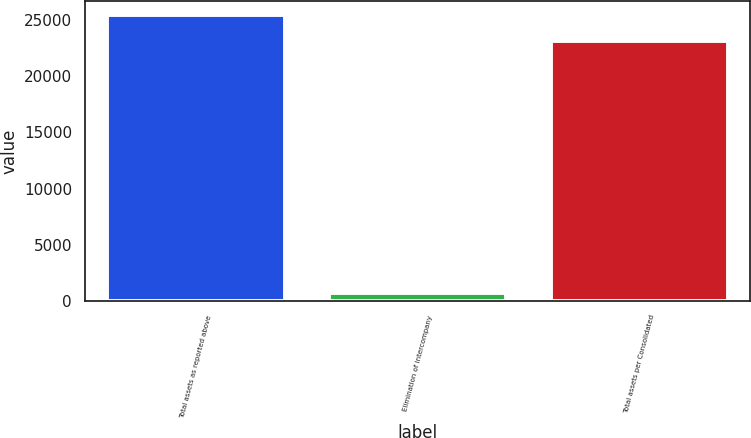<chart> <loc_0><loc_0><loc_500><loc_500><bar_chart><fcel>Total assets as reported above<fcel>Elimination of intercompany<fcel>Total assets per Consolidated<nl><fcel>25406.7<fcel>700<fcel>23097<nl></chart> 